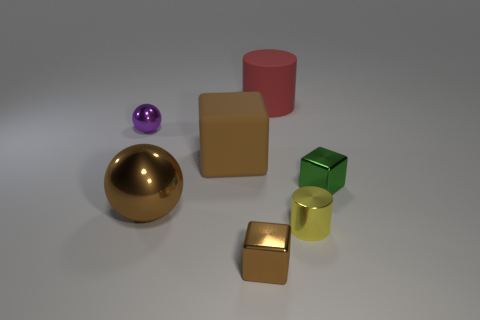Are there more brown metal spheres to the right of the large brown rubber thing than shiny balls right of the small brown shiny object?
Ensure brevity in your answer.  No. Do the tiny cube right of the big red thing and the ball that is in front of the small metal ball have the same material?
Offer a very short reply. Yes. There is a big ball; are there any tiny green metal things behind it?
Your answer should be very brief. Yes. How many red things are large blocks or large cylinders?
Your answer should be compact. 1. Are the red cylinder and the ball that is behind the green shiny object made of the same material?
Your response must be concise. No. What size is the yellow thing that is the same shape as the red rubber object?
Give a very brief answer. Small. What material is the big red cylinder?
Offer a terse response. Rubber. There is a ball left of the large thing that is left of the brown cube that is behind the green thing; what is its material?
Give a very brief answer. Metal. Does the shiny thing to the right of the small metal cylinder have the same size as the cylinder that is behind the big ball?
Make the answer very short. No. What number of other objects are the same material as the big cylinder?
Offer a very short reply. 1. 